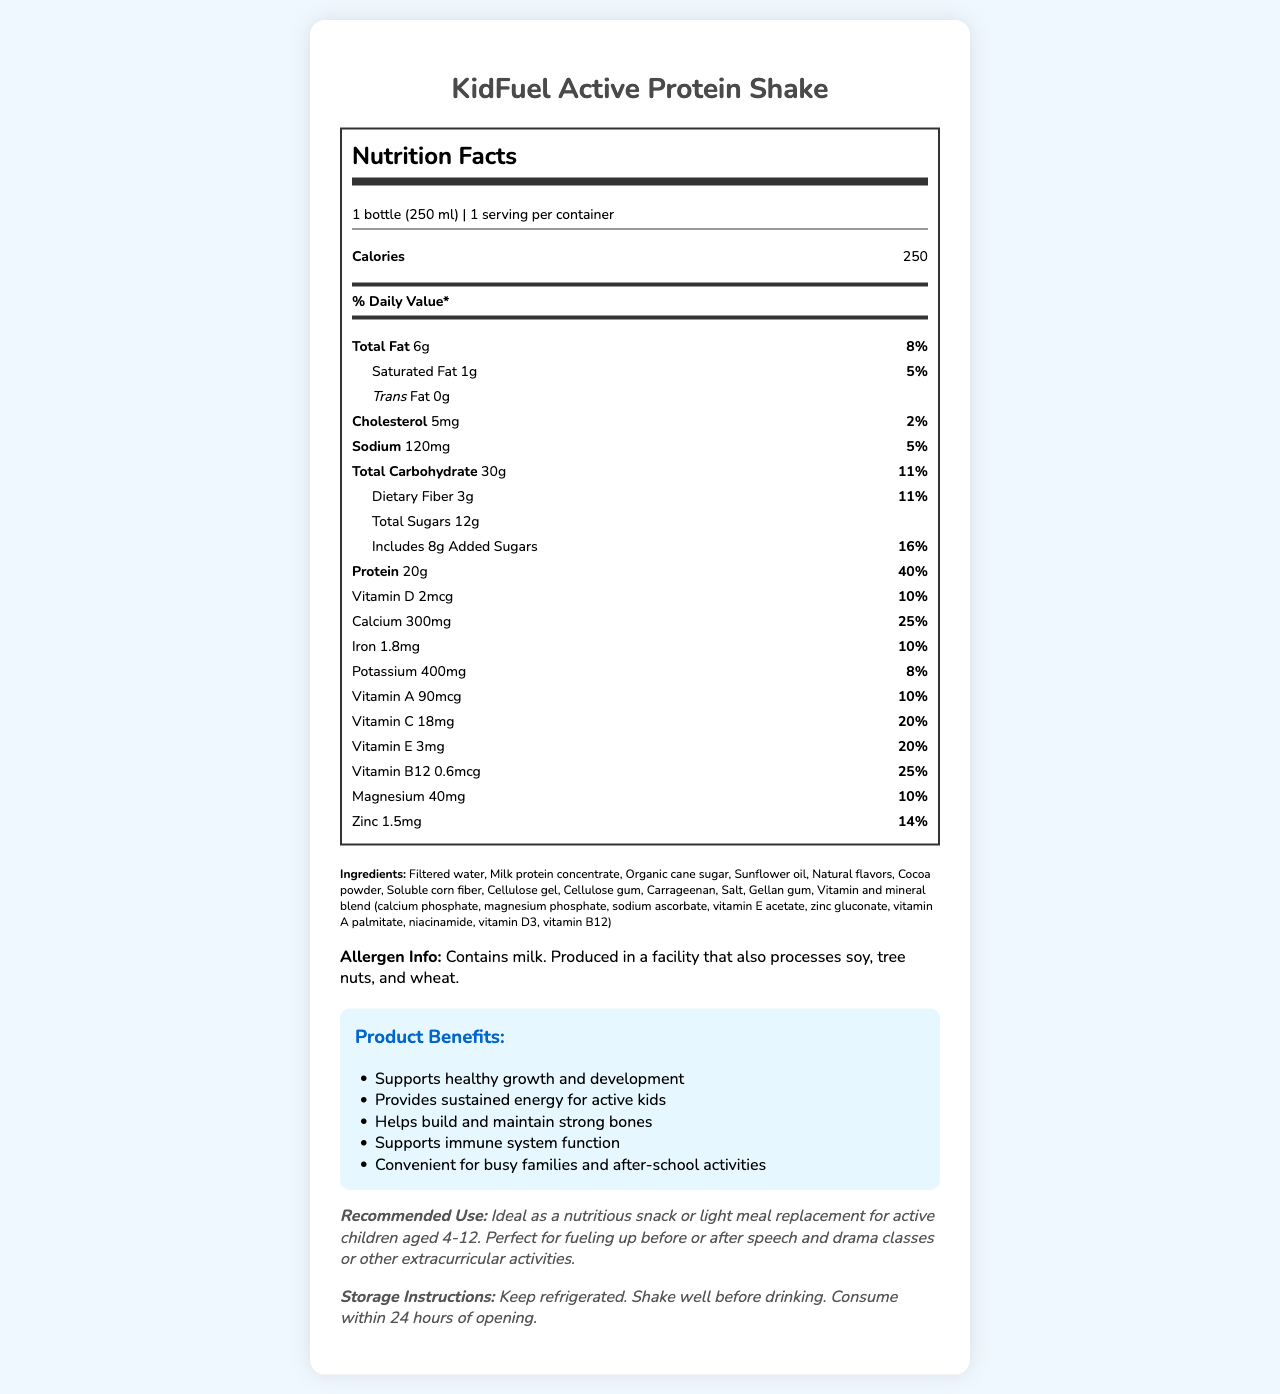what is the serving size for KidFuel Active Protein Shake? The serving size is displayed under the title "Nutrition Facts" and is stated as "1 bottle (250 ml)".
Answer: 1 bottle (250 ml) How many calories are in one serving of the KidFuel Active Protein Shake? The calorie count is displayed under the "Nutrition Facts" heading and lists "Calories" as 250.
Answer: 250 What is the amount of protein per serving and its daily value percentage? The amount of protein and its daily value percentage are displayed under the "Nutrition Facts" section, stating "Protein 20g" and "40%" respectively.
Answer: 20g, 40% How much dietary fiber does one serving of the shake contain and its daily value percentage? The dietary fiber content and its daily value percentage are listed under "Total Carbohydrate" as "Dietary Fiber 3g" and "11%".
Answer: 3g, 11% Which vitamins are included in the KidFuel Active Protein Shake? The vitamins included are listed individually with their amounts and daily values under the "Nutrition Facts".
Answer: Vitamin D, Calcium, Iron, Potassium, Vitamin A, Vitamin C, Vitamin E, Vitamin B12, Magnesium, Zinc What are the ingredients of KidFuel Active Protein Shake? The ingredients are listed under the "Ingredients" section in the document.
Answer: Filtered water, Milk protein concentrate, Organic cane sugar, Sunflower oil, Natural flavors, Cocoa powder, Soluble corn fiber, Cellulose gel, Cellulose gum, Carrageenan, Salt, Gellan gum, Vitamin and mineral blend (calcium phosphate, magnesium phosphate, sodium ascorbate, vitamin E acetate, zinc gluconate, vitamin A palmitate, niacinamide, vitamin D3, vitamin B12) Is the KidFuel Active Protein Shake suitable for someone with a dairy allergy? The allergen information at the bottom of the document states, "Contains milk."
Answer: No Which of the following is a benefit mentioned for KidFuel Active Protein Shake? A. Supports healthy sleep B. Supports healthy growth and development C. Enhances academic performance D. Reduces stress The "Product Benefits" section mentions "Supports healthy growth and development" as one of the benefits.
Answer: B How much added sugar is in one serving and what is its daily value percentage? A. 6g, 12% B. 8g, 16% C. 10g, 20% D. 12g, 24% The "Total Sugars" section specifies "Includes 8g Added Sugars," with a daily value of "16%."
Answer: B True or False: The product provides 25% of the daily recommended amount of Vitamin C. The document states that Vitamin C in the product is 18mg, which corresponds to 20% of the daily value.
Answer: False Summarize the main features of KidFuel Active Protein Shake as presented in the document. The document outlines the product's nutrition facts, ingredients, benefits, recommended use, and storage instructions.
Answer: KidFuel Active Protein Shake is a nutrition-dense drink designed for active kids, with each serving containing 250 calories and 20g of protein. It includes various vitamins and minerals and is recommended for children aged 4-12 as a snack or light meal replacement. The shake supports healthy growth, provides sustained energy, and helps build strong bones. It contains ingredients such as filtered water, milk protein concentrate, and organic cane sugar, and comes with allergen information noting the presence of milk. The product should be refrigerated and consumed within 24 hours of opening. How does the product help in maintaining strong bones? The benefits section mentions that the product helps build and maintain strong bones, supported by the presence of calcium (300mg, 25% DV) and Vitamin D (2mcg, 10% DV).
Answer: Contains Calcium and Vitamin D Does the KidFuel Active Protein Shake contain any iron, and if so, how much? The nutrition facts list Iron content as "1.8mg" with a daily value percentage of "10%."
Answer: Yes, 1.8mg What is the trans fat content in one serving of KidFuel Active Protein Shake? The trans fat content is listed in the "Nutrition Facts" section under "Total Fat," showing "Trans Fat 0g."
Answer: 0g What specific allergy information is provided for this product? The allergen info section specifies the presence of milk and potential cross-contamination with soy, tree nuts, and wheat.
Answer: Contains milk. Produced in a facility that also processes soy, tree nuts, and wheat. What type of fiber is included in the KidFuel Active Protein Shake? The ingredient list includes "Soluble corn fiber" as one of the fibers present in the product.
Answer: Soluble corn fiber Can this product aid in immune system function, according to the document? Under the "Product Benefits" section, it is stated that the shake "Supports immune system function."
Answer: Yes What is the daily value percentage of vitamin B12 in the shake? The "Nutrition Facts" lists Vitamin B12 with a daily value of "25%."
Answer: 25% When should the KidFuel Active Protein Shake ideally be consumed for active children aged 4-12? The "Recommended Use" section advises consuming the shake as a nutritious snack or light meal replacement before or after activities.
Answer: Before or after speech and drama classes or other extracurricular activities. Are there any artificial sweeteners listed in the ingredients? The ingredients listed do not mention any artificial sweeteners.
Answer: No What is the total carbohydrate amount per serving in the shake? The "Nutrition Facts" section lists "Total Carbohydrate" as 30g.
Answer: 30g What are the storage instructions for the KidFuel Active Protein Shake? The storage instructions are clearly stated under the "Storage Instructions" section.
Answer: Keep refrigerated. Shake well before drinking. Consume within 24 hours of opening. How much Vitamin A is in one serving of the KidFuel Active Protein Shake? The "Nutrition Facts" lists the Vitamin A content as "90mcg".
Answer: 90mcg How many servings are in each container of KidFuel Active Protein Shake? The "Nutrition Facts" mentions that there is "1 serving per container."
Answer: 1 Can you tell the exact date of manufacture from this document? The document does not provide the date of manufacture, hence, this information cannot be determined.
Answer: Not enough information What is the benefit of the inclusion of magnesium in the KidFuel Active Protein Shake? The document specifies the amount and daily value percentage of magnesium but does not detail its specific benefits.
Answer: Not specified 